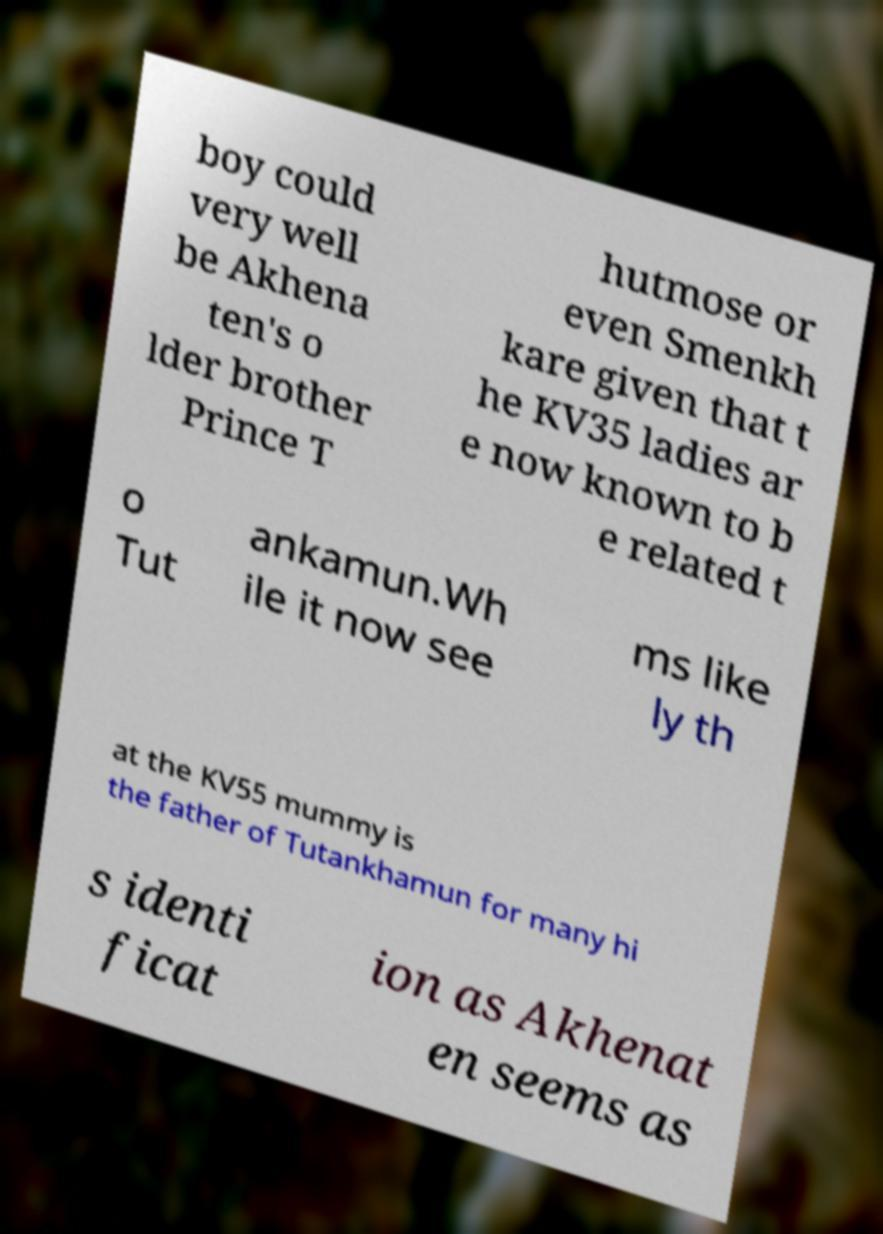I need the written content from this picture converted into text. Can you do that? boy could very well be Akhena ten's o lder brother Prince T hutmose or even Smenkh kare given that t he KV35 ladies ar e now known to b e related t o Tut ankamun.Wh ile it now see ms like ly th at the KV55 mummy is the father of Tutankhamun for many hi s identi ficat ion as Akhenat en seems as 